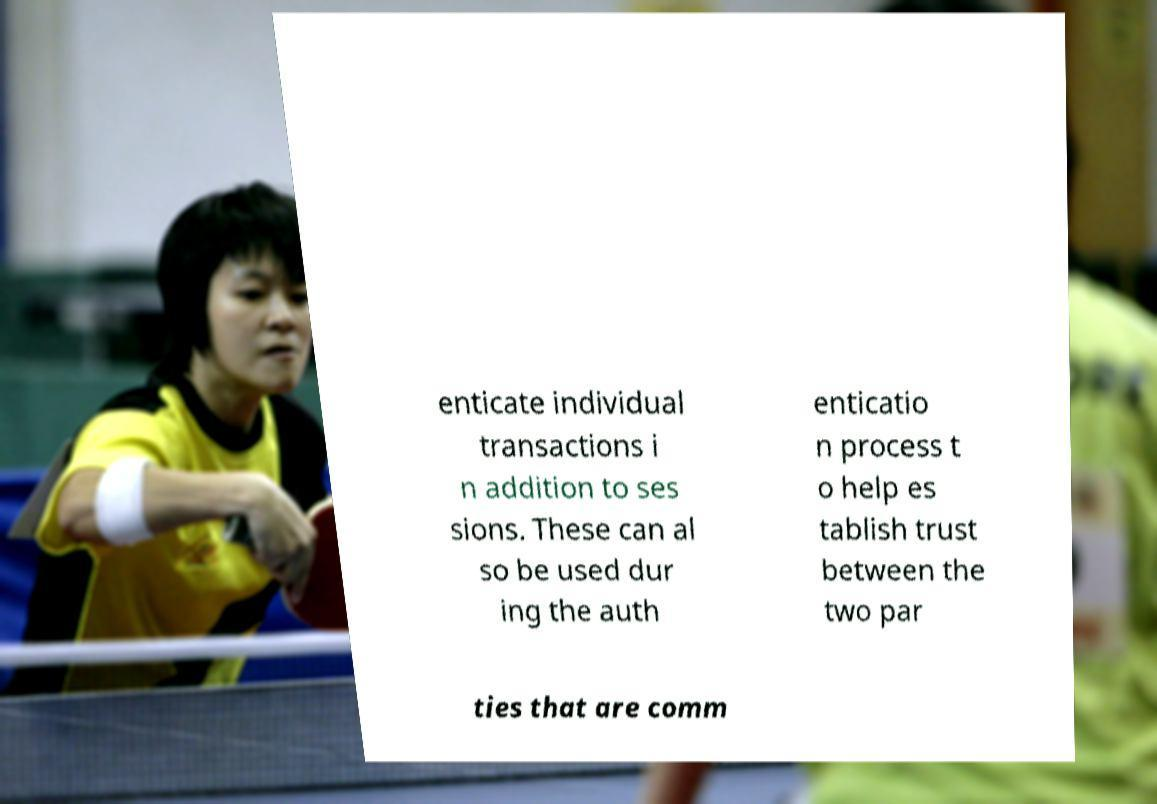There's text embedded in this image that I need extracted. Can you transcribe it verbatim? enticate individual transactions i n addition to ses sions. These can al so be used dur ing the auth enticatio n process t o help es tablish trust between the two par ties that are comm 